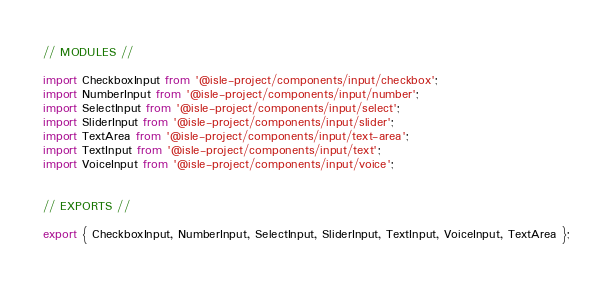<code> <loc_0><loc_0><loc_500><loc_500><_JavaScript_>// MODULES //

import CheckboxInput from '@isle-project/components/input/checkbox';
import NumberInput from '@isle-project/components/input/number';
import SelectInput from '@isle-project/components/input/select';
import SliderInput from '@isle-project/components/input/slider';
import TextArea from '@isle-project/components/input/text-area';
import TextInput from '@isle-project/components/input/text';
import VoiceInput from '@isle-project/components/input/voice';


// EXPORTS //

export { CheckboxInput, NumberInput, SelectInput, SliderInput, TextInput, VoiceInput, TextArea };
</code> 